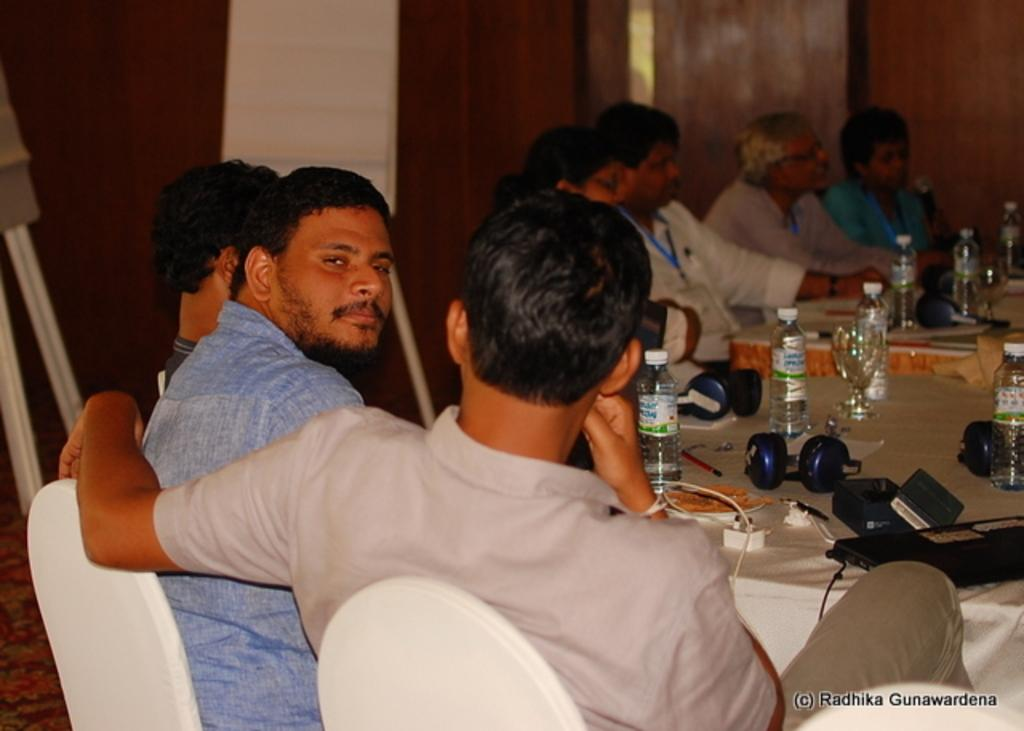What are the people in the image doing? There is a group of people seated on chairs in the image. What items can be seen on the table in the image? There are bottles, headphones, a laptop, and a mobile charger on the table in the image. What type of skin condition is visible on the laptop in the image? There is no skin condition visible on the laptop in the image, as laptops do not have skin. 